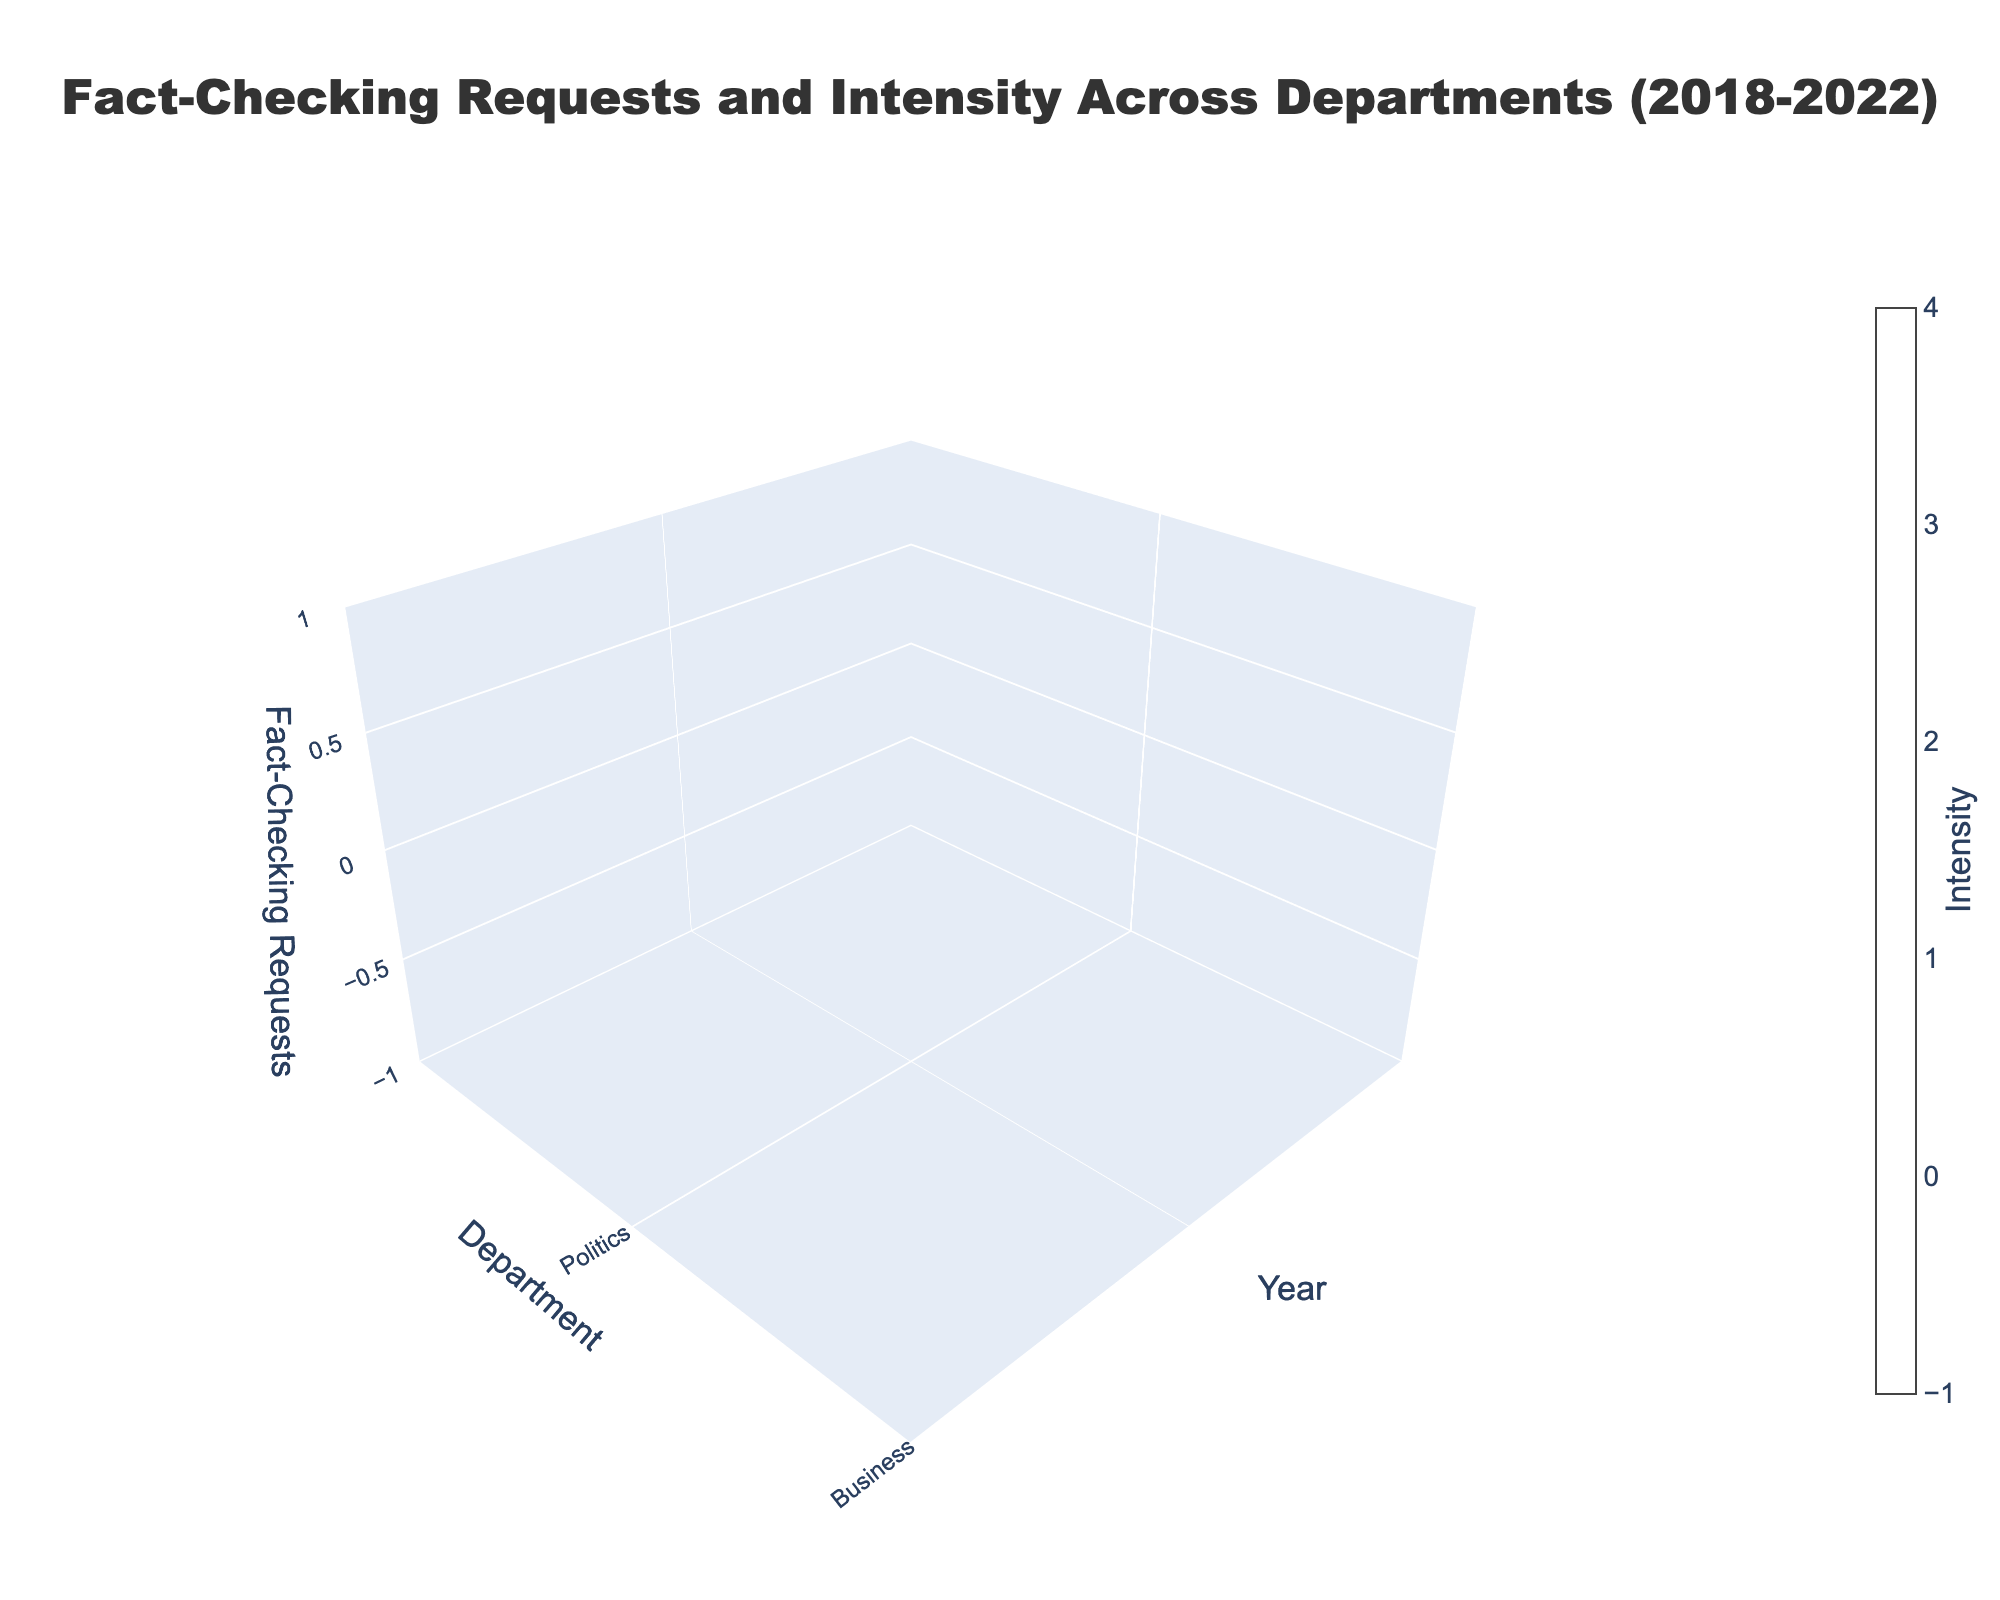What is the title of the 3D volume plot? The title is found at the top of the figure and gives an overview of the plot's content.
Answer: "Fact-Checking Requests and Intensity Across Departments (2018-2022)" What is the z-axis labeled in the plot? The z-axis label can be read from the plot to understand what data dimension it represents.
Answer: "Fact-Checking Requests" In which year did the Politics department have the highest number of fact-checking requests? By examining the 'Politics' data points across the years, we see that the highest z-value for Politics is in 2022.
Answer: 2022 What is the average Intensity of the Technology department from 2018 to 2022? Add the intensities for the Technology department across all years and divide by the number of years: (2.5 + 2.7 + 3.0 + 2.9 + 3.2)/5 = 14.3/5 = 2.86
Answer: 2.86 Which department had the lowest intensity value in 2020? Checking the intensity values for all departments in 2020, the lowest is 2.4 for Entertainment.
Answer: Entertainment Compare the number of fact-checking requests between the Business and Entertainment departments in 2021. Which department had more requests and by how much? The plot shows that Business had 100 requests and Entertainment had 60 requests in 2021; the difference is 100 - 60 = 40.
Answer: Business, by 40 How did the intensity for the Politics department change from 2018 to 2022? Check the intensity values for Politics over the years. From 3.2 in 2018 to 4.3 in 2022, there is an increase of 4.3 - 3.2 = 1.1.
Answer: Increased by 1.1 Which department had the most significant increase in fact-checking requests from 2019 to 2020? Compare the changes in requests for each department from 2019 to 2020. Politics had the most significant increase, from 150 to 200, which is 200 - 150 = 50.
Answer: Politics What is the overall trend in the number of fact-checking requests for the Business department from 2018 to 2022? Note the requests across years: 80 (2018), 90 (2019), 110 (2020), 100 (2021), 120 (2022). The trend shows a general increase with slight fluctuations.
Answer: Increasing trend Which year had the highest overall intensity for fact-checking requests across all departments? Sum intensities for each year and compare: 
2018: 3.2+2.8+2.5+1.9 = 10.4 
2019: 3.5+3.0+2.7+2.1 = 11.3 
2020: 4.1+3.3+3.0+2.4 = 12.8 
2021: 3.8+3.1+2.9+2.2 = 12.0 
2022: 4.3+3.5+3.2+2.6 = 13.6 
2022 has the highest total.
Answer: 2022 